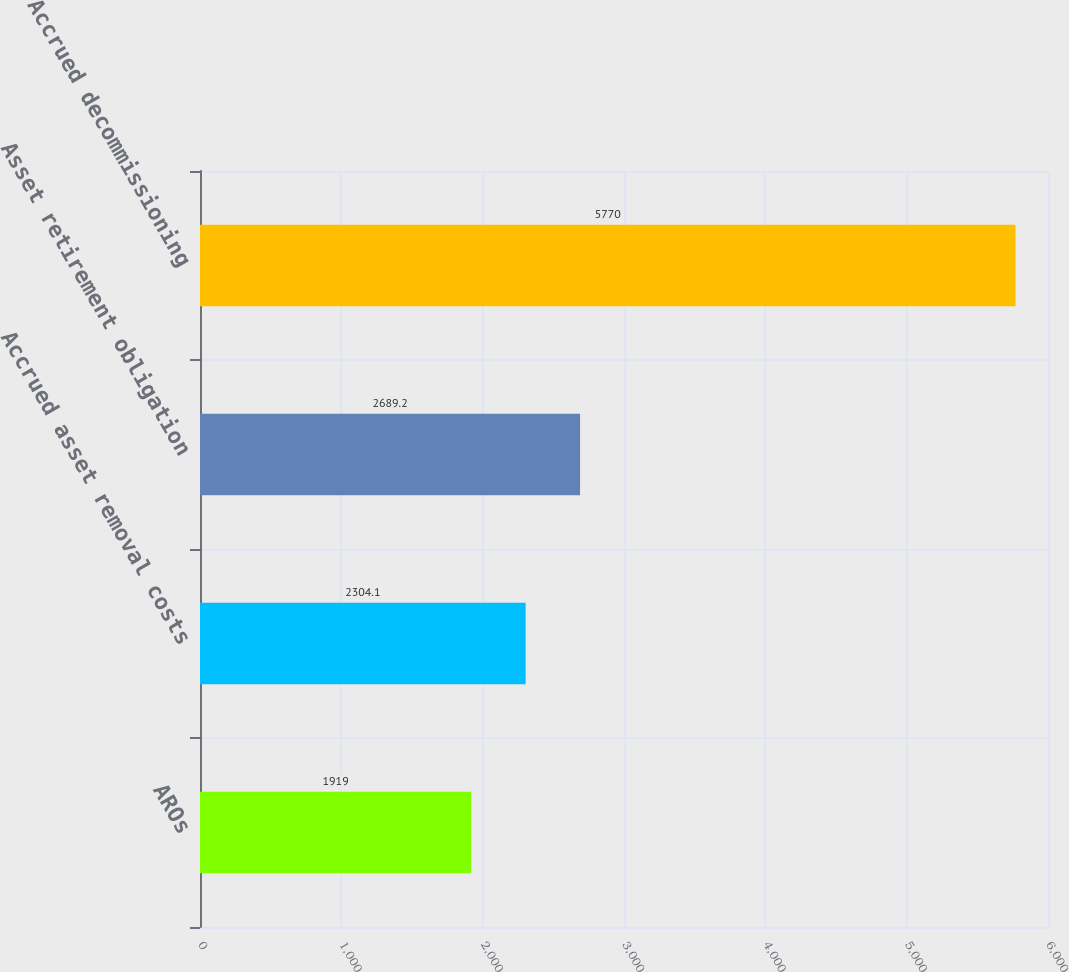Convert chart to OTSL. <chart><loc_0><loc_0><loc_500><loc_500><bar_chart><fcel>AROs<fcel>Accrued asset removal costs<fcel>Asset retirement obligation<fcel>Accrued decommissioning<nl><fcel>1919<fcel>2304.1<fcel>2689.2<fcel>5770<nl></chart> 